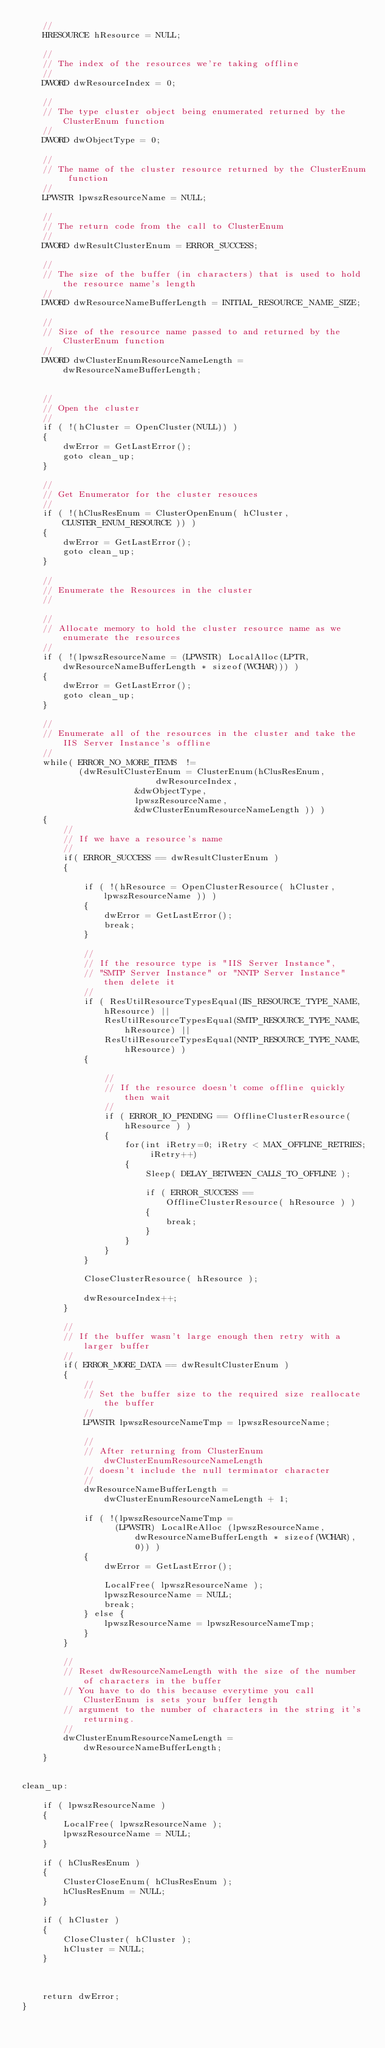<code> <loc_0><loc_0><loc_500><loc_500><_C++_>	// 
	HRESOURCE hResource = NULL;

	//
	// The index of the resources we're taking offline
	//
	DWORD dwResourceIndex = 0;

	//
	// The type cluster object being enumerated returned by the ClusterEnum function
	//
	DWORD dwObjectType = 0;

	//
	// The name of the cluster resource returned by the ClusterEnum function
	//
	LPWSTR lpwszResourceName = NULL;
	
	//
	// The return code from the call to ClusterEnum
	//
	DWORD dwResultClusterEnum = ERROR_SUCCESS;

	//
	// The size of the buffer (in characters) that is used to hold the resource name's length
	//	
	DWORD dwResourceNameBufferLength = INITIAL_RESOURCE_NAME_SIZE;

	//
	// Size of the resource name passed to and returned by the ClusterEnum function
	//	
	DWORD dwClusterEnumResourceNameLength = dwResourceNameBufferLength;


	//
	// Open the cluster
	//
	if ( !(hCluster = OpenCluster(NULL)) )
	{
		dwError = GetLastError();
		goto clean_up;
	}

	//
	// Get Enumerator for the cluster resouces
	// 
	if ( !(hClusResEnum = ClusterOpenEnum( hCluster, CLUSTER_ENUM_RESOURCE )) )
	{
		dwError = GetLastError();
		goto clean_up;	
	}
	
	//
	// Enumerate the Resources in the cluster
	// 
	
	//
	// Allocate memory to hold the cluster resource name as we enumerate the resources
	//
	if ( !(lpwszResourceName = (LPWSTR) LocalAlloc(LPTR, dwResourceNameBufferLength * sizeof(WCHAR))) )
	{
		dwError = GetLastError();
		goto clean_up;
	}

	// 
	// Enumerate all of the resources in the cluster and take the IIS Server Instance's offline
	//
	while( ERROR_NO_MORE_ITEMS  != 
	       (dwResultClusterEnum = ClusterEnum(hClusResEnum,
			              dwResourceIndex, 
				      &dwObjectType, 
				      lpwszResourceName,
				      &dwClusterEnumResourceNameLength )) )
	{		
		//
		// If we have a resource's name
		//
		if( ERROR_SUCCESS == dwResultClusterEnum )
		{

			if ( !(hResource = OpenClusterResource( hCluster, lpwszResourceName )) )
			{
				dwError = GetLastError();
				break;
			}

			//
			// If the resource type is "IIS Server Instance",
			// "SMTP Server Instance" or "NNTP Server Instance" then delete it
			//
			if ( ResUtilResourceTypesEqual(IIS_RESOURCE_TYPE_NAME, hResource) || 
                ResUtilResourceTypesEqual(SMTP_RESOURCE_TYPE_NAME, hResource) || 
                ResUtilResourceTypesEqual(NNTP_RESOURCE_TYPE_NAME, hResource) )
			{

				//
				// If the resource doesn't come offline quickly then wait 
				//
				if ( ERROR_IO_PENDING == OfflineClusterResource( hResource ) )
				{
					for(int iRetry=0; iRetry < MAX_OFFLINE_RETRIES; iRetry++)
					{
						Sleep( DELAY_BETWEEN_CALLS_TO_OFFLINE );

						if ( ERROR_SUCCESS == OfflineClusterResource( hResource ) )
						{
							break;
						}
					}	
				}
			}

			CloseClusterResource( hResource );
			
			dwResourceIndex++;
		}
			
		//
		// If the buffer wasn't large enough then retry with a larger buffer
		//
		if( ERROR_MORE_DATA == dwResultClusterEnum )
		{
			//
			// Set the buffer size to the required size reallocate the buffer
			//
			LPWSTR lpwszResourceNameTmp = lpwszResourceName;

			//
			// After returning from ClusterEnum dwClusterEnumResourceNameLength 
			// doesn't include the null terminator character
			//
			dwResourceNameBufferLength = dwClusterEnumResourceNameLength + 1;

			if ( !(lpwszResourceNameTmp = 
			      (LPWSTR) LocalReAlloc (lpwszResourceName, dwResourceNameBufferLength * sizeof(WCHAR), 0)) )
			{
				dwError = GetLastError();

				LocalFree( lpwszResourceName );	
				lpwszResourceName = NULL;
				break;
			} else {
				lpwszResourceName = lpwszResourceNameTmp;
			}
		}

		//
		// Reset dwResourceNameLength with the size of the number of characters in the buffer
		// You have to do this because everytime you call ClusterEnum is sets your buffer length 
		// argument to the number of characters in the string it's returning.
		//
		dwClusterEnumResourceNameLength = dwResourceNameBufferLength;
	}	


clean_up:

	if ( lpwszResourceName )
	{
		LocalFree( lpwszResourceName );
		lpwszResourceName = NULL;
	}
	
	if ( hClusResEnum )
	{
		ClusterCloseEnum( hClusResEnum );
		hClusResEnum = NULL;
	}

	if ( hCluster )
	{
		CloseCluster( hCluster );
		hCluster = NULL;
	}
			


	return dwError;
}
</code> 